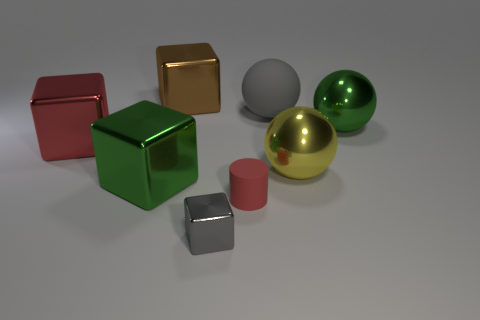Subtract all yellow cubes. Subtract all yellow balls. How many cubes are left? 4 Add 1 big green metal cubes. How many objects exist? 9 Subtract all cylinders. How many objects are left? 7 Subtract all big brown cubes. Subtract all big green balls. How many objects are left? 6 Add 5 shiny spheres. How many shiny spheres are left? 7 Add 5 brown metallic cubes. How many brown metallic cubes exist? 6 Subtract 0 purple cylinders. How many objects are left? 8 